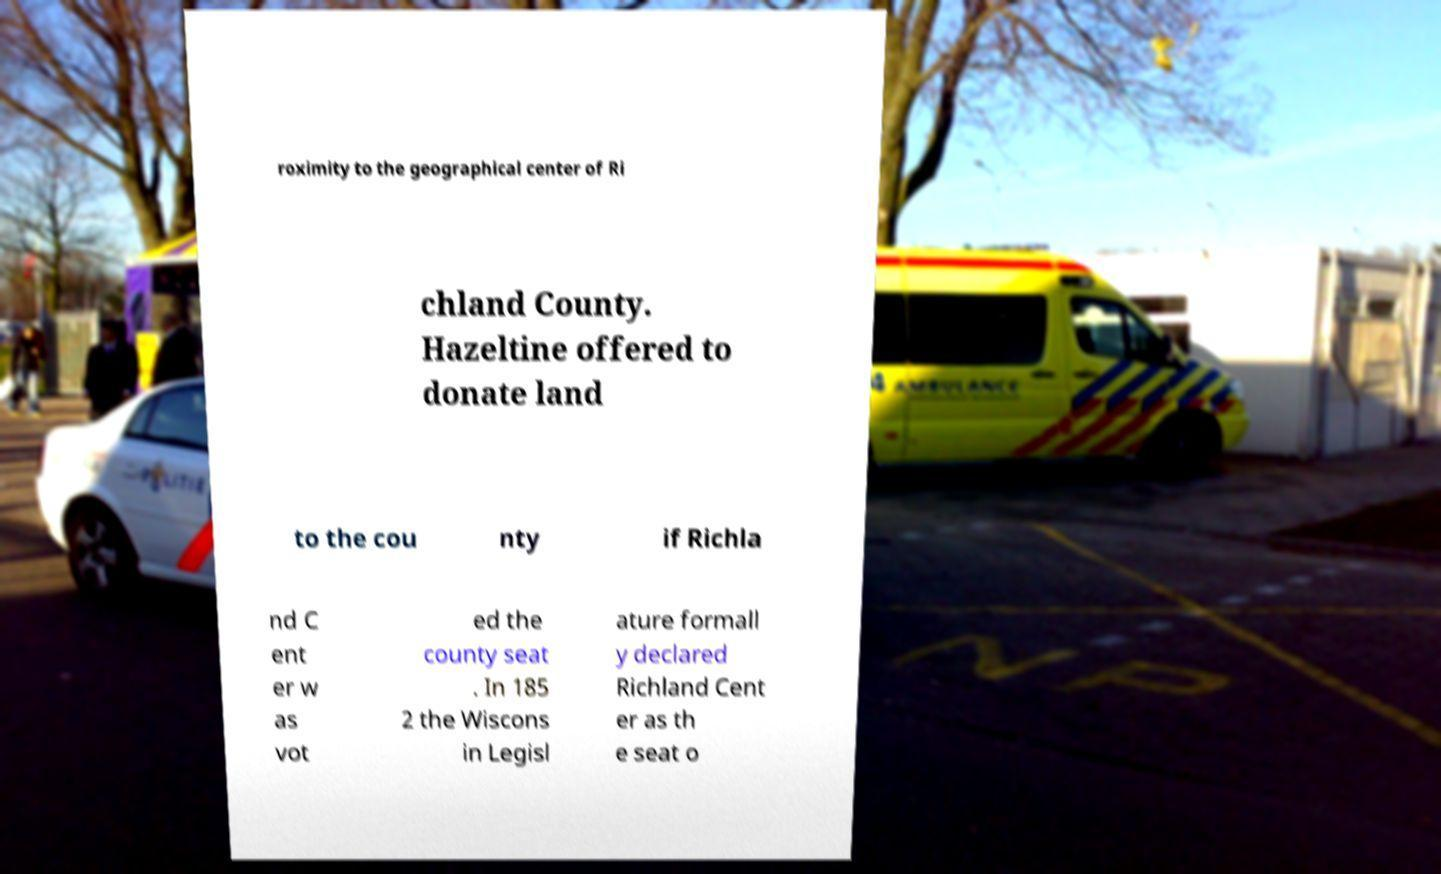What messages or text are displayed in this image? I need them in a readable, typed format. roximity to the geographical center of Ri chland County. Hazeltine offered to donate land to the cou nty if Richla nd C ent er w as vot ed the county seat . In 185 2 the Wiscons in Legisl ature formall y declared Richland Cent er as th e seat o 